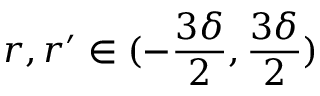Convert formula to latex. <formula><loc_0><loc_0><loc_500><loc_500>r , r ^ { \prime } \in ( - \frac { 3 \delta } 2 , \frac { 3 \delta } 2 )</formula> 